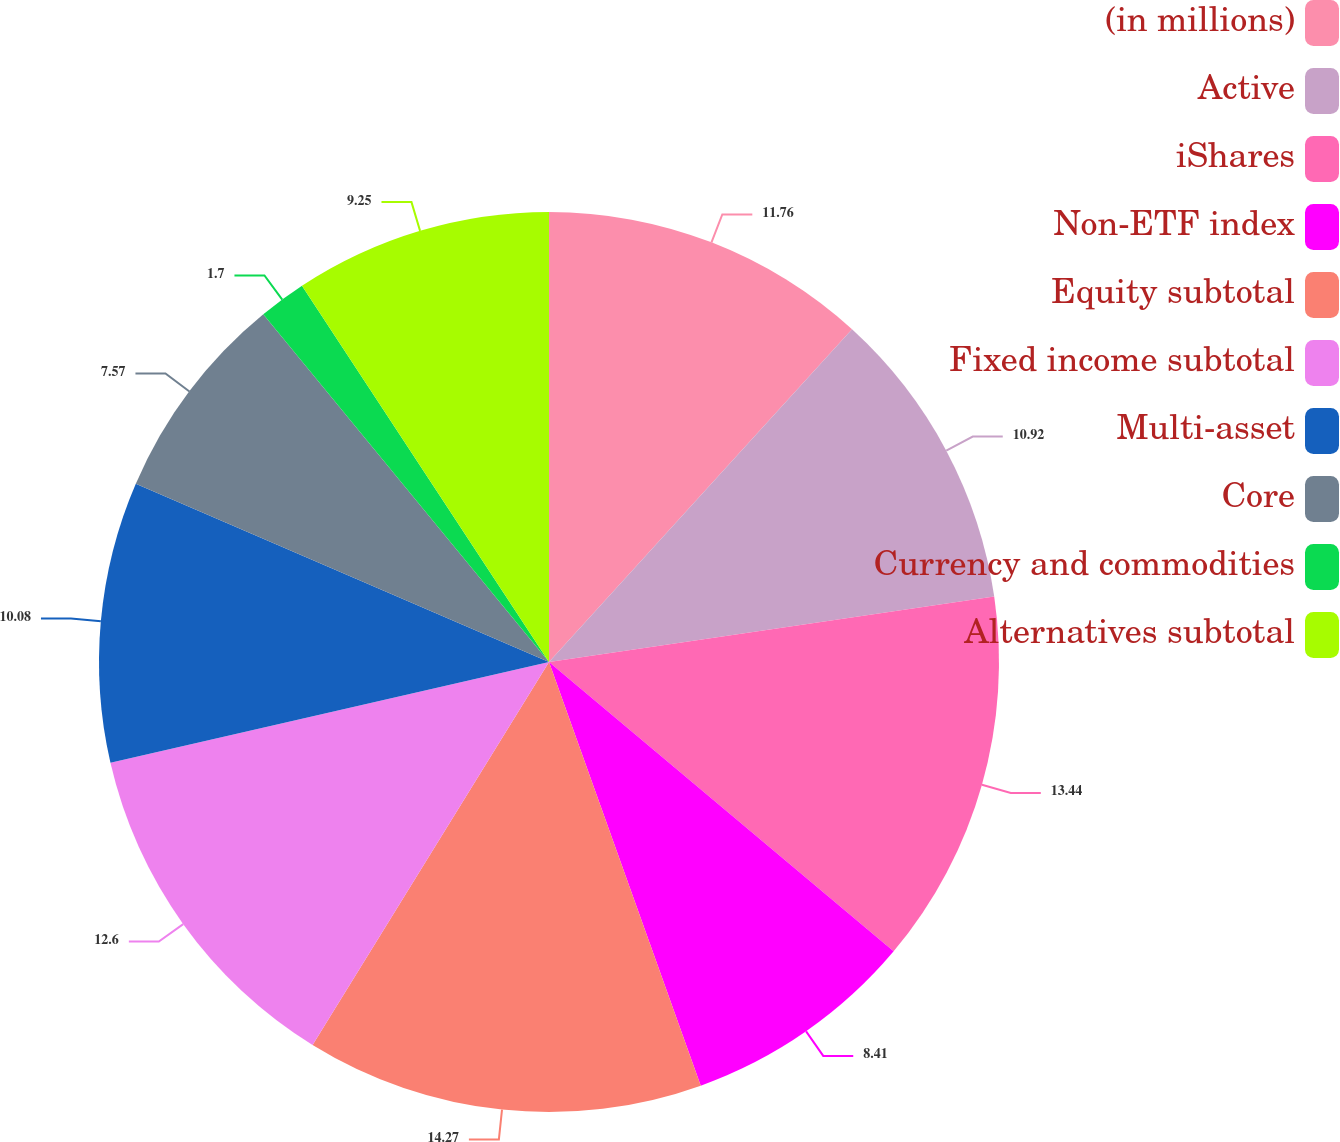Convert chart. <chart><loc_0><loc_0><loc_500><loc_500><pie_chart><fcel>(in millions)<fcel>Active<fcel>iShares<fcel>Non-ETF index<fcel>Equity subtotal<fcel>Fixed income subtotal<fcel>Multi-asset<fcel>Core<fcel>Currency and commodities<fcel>Alternatives subtotal<nl><fcel>11.76%<fcel>10.92%<fcel>13.44%<fcel>8.41%<fcel>14.28%<fcel>12.6%<fcel>10.08%<fcel>7.57%<fcel>1.7%<fcel>9.25%<nl></chart> 